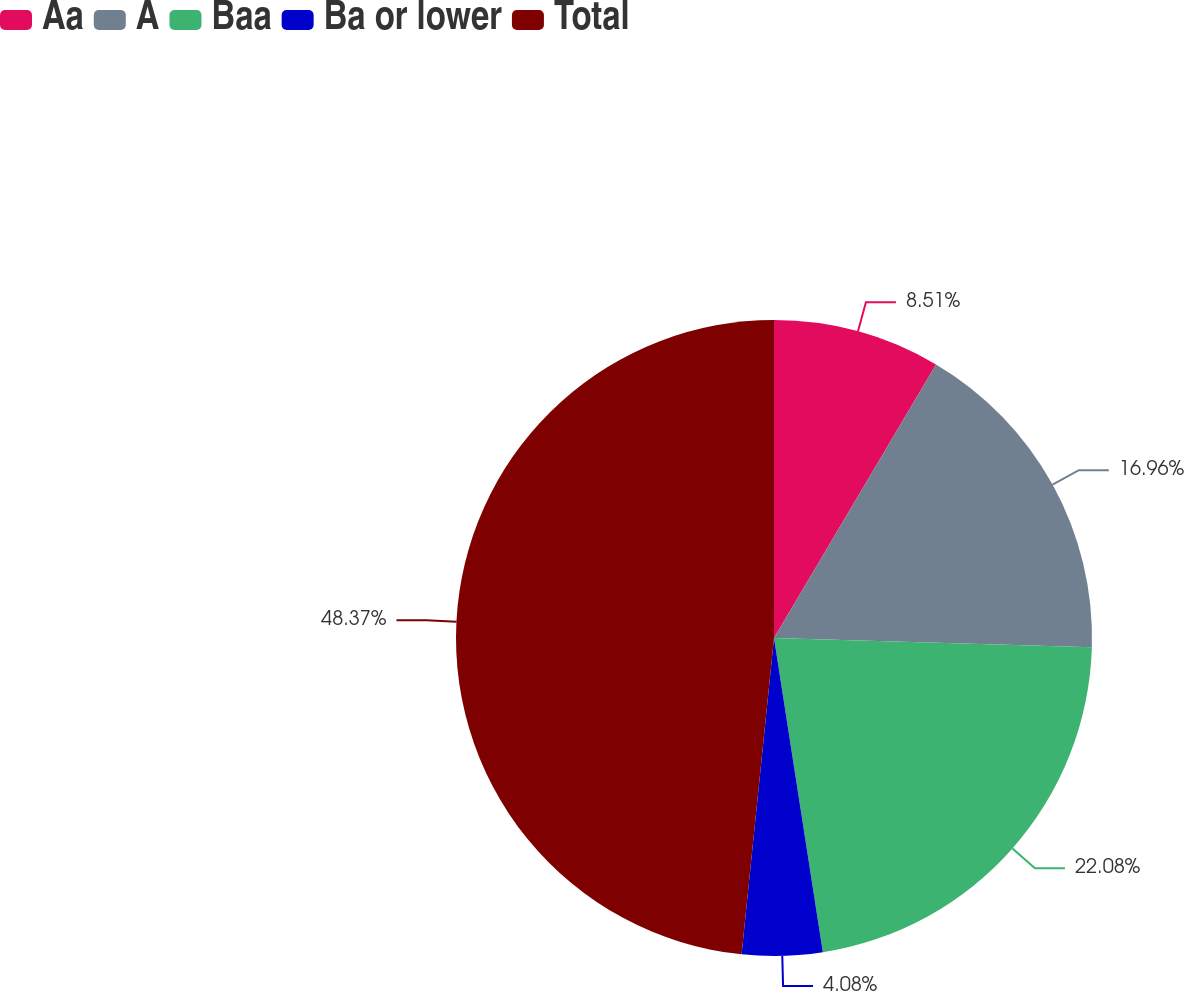Convert chart. <chart><loc_0><loc_0><loc_500><loc_500><pie_chart><fcel>Aa<fcel>A<fcel>Baa<fcel>Ba or lower<fcel>Total<nl><fcel>8.51%<fcel>16.96%<fcel>22.08%<fcel>4.08%<fcel>48.38%<nl></chart> 